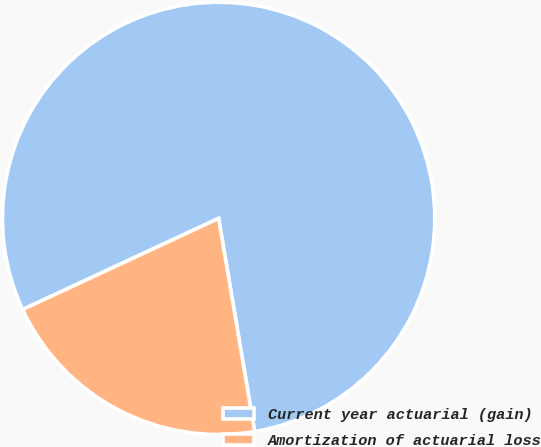Convert chart. <chart><loc_0><loc_0><loc_500><loc_500><pie_chart><fcel>Current year actuarial (gain)<fcel>Amortization of actuarial loss<nl><fcel>79.26%<fcel>20.74%<nl></chart> 